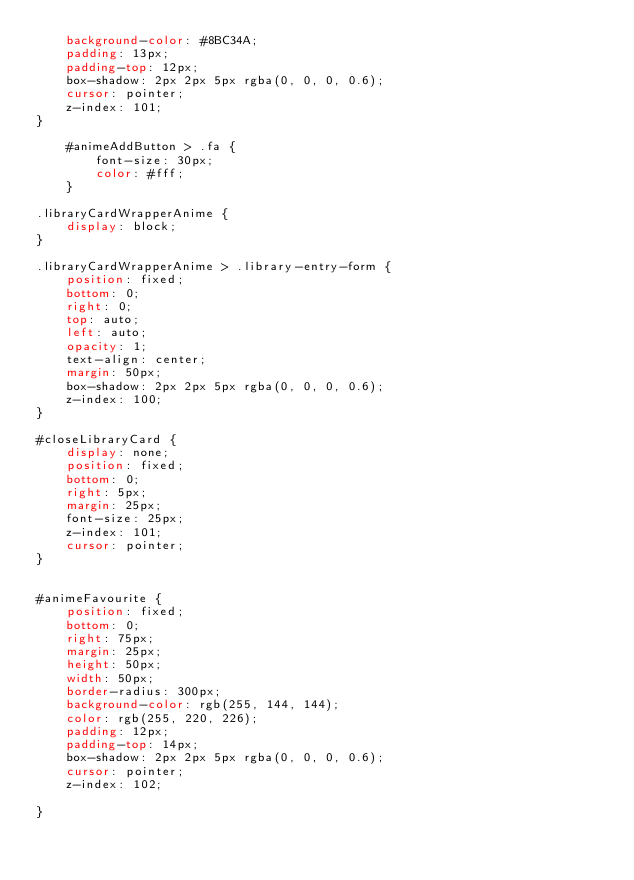<code> <loc_0><loc_0><loc_500><loc_500><_CSS_>	background-color: #8BC34A;
	padding: 13px;
	padding-top: 12px;
	box-shadow: 2px 2px 5px rgba(0, 0, 0, 0.6); 
	cursor: pointer;
	z-index: 101;
}

	#animeAddButton > .fa {
		font-size: 30px;
		color: #fff;
	}

.libraryCardWrapperAnime {
	display: block;
}

.libraryCardWrapperAnime > .library-entry-form {
	position: fixed;
	bottom: 0;
	right: 0;
	top: auto;
	left: auto;
	opacity: 1;
	text-align: center;
	margin: 50px;
	box-shadow: 2px 2px 5px rgba(0, 0, 0, 0.6); 
	z-index: 100;
}

#closeLibraryCard {
	display: none;
	position: fixed;
	bottom: 0;
	right: 5px;
	margin: 25px;
	font-size: 25px;
	z-index: 101;
	cursor: pointer;
}


#animeFavourite {
	position: fixed;
	bottom: 0;
	right: 75px;
	margin: 25px;
	height: 50px;
	width: 50px;
	border-radius: 300px;
	background-color: rgb(255, 144, 144);
	color: rgb(255, 220, 226);
	padding: 12px;
	padding-top: 14px;
	box-shadow: 2px 2px 5px rgba(0, 0, 0, 0.6);
	cursor: pointer;
	z-index: 102;

}
</code> 